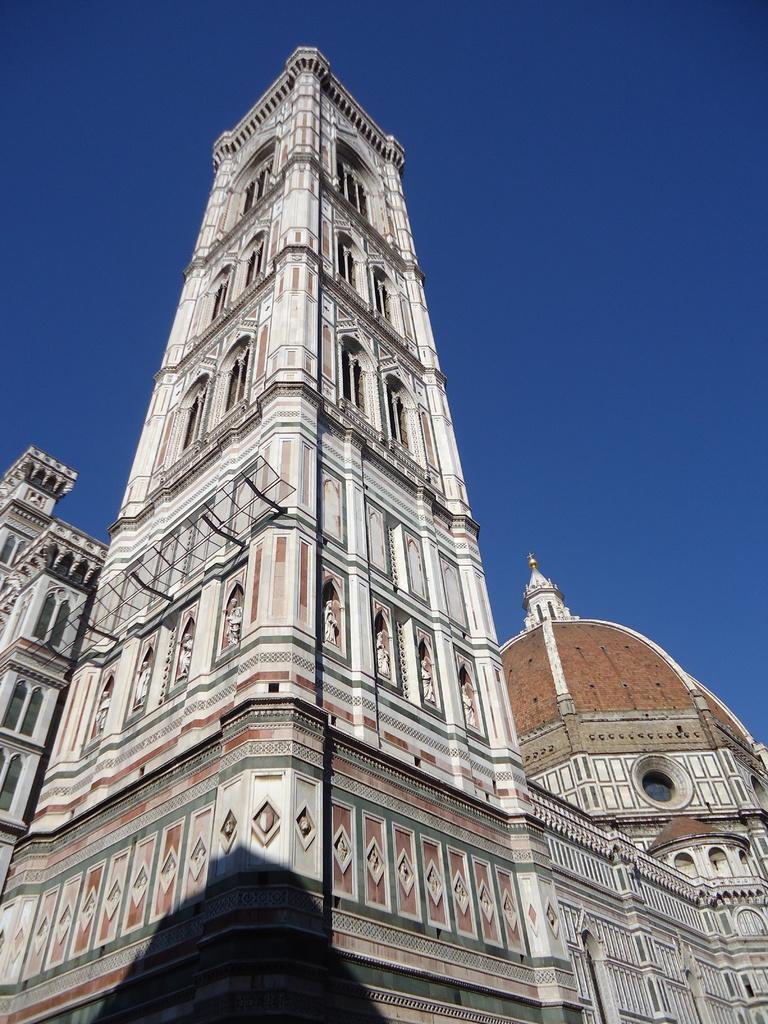Please provide a concise description of this image. In this image in front there are buildings. In the background of the image there is sky. 